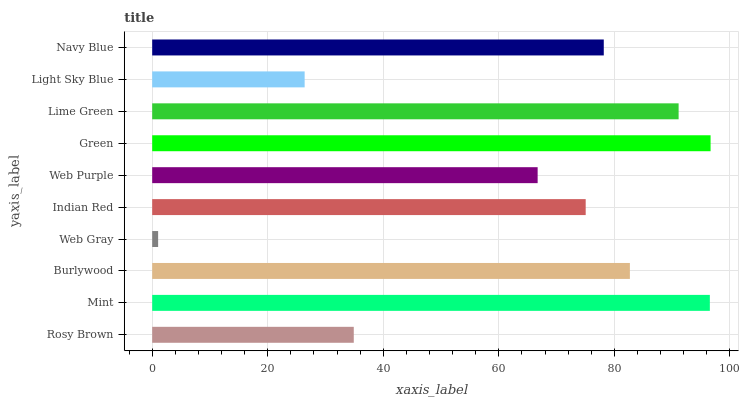Is Web Gray the minimum?
Answer yes or no. Yes. Is Green the maximum?
Answer yes or no. Yes. Is Mint the minimum?
Answer yes or no. No. Is Mint the maximum?
Answer yes or no. No. Is Mint greater than Rosy Brown?
Answer yes or no. Yes. Is Rosy Brown less than Mint?
Answer yes or no. Yes. Is Rosy Brown greater than Mint?
Answer yes or no. No. Is Mint less than Rosy Brown?
Answer yes or no. No. Is Navy Blue the high median?
Answer yes or no. Yes. Is Indian Red the low median?
Answer yes or no. Yes. Is Web Purple the high median?
Answer yes or no. No. Is Light Sky Blue the low median?
Answer yes or no. No. 